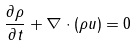<formula> <loc_0><loc_0><loc_500><loc_500>\ { \frac { \partial \rho } { \partial t } } + \nabla \cdot ( \rho u ) = 0</formula> 